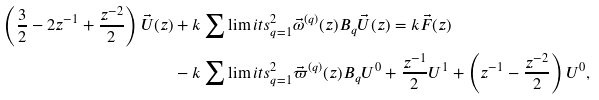<formula> <loc_0><loc_0><loc_500><loc_500>\left ( \frac { 3 } { 2 } - 2 z ^ { - 1 } + \frac { z ^ { - 2 } } { 2 } \right ) \vec { U } ( z ) & + k \sum \lim i t s _ { q = 1 } ^ { 2 } \vec { \omega } ^ { ( q ) } ( z ) B _ { q } \vec { U } ( z ) = k \vec { F } ( z ) \\ & - k \sum \lim i t s _ { q = 1 } ^ { 2 } \vec { \varpi } ^ { ( q ) } ( z ) B _ { q } U ^ { 0 } + \frac { z ^ { - 1 } } { 2 } U ^ { 1 } + \left ( z ^ { - 1 } - \frac { z ^ { - 2 } } { 2 } \right ) U ^ { 0 } ,</formula> 